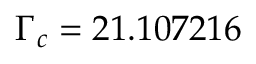Convert formula to latex. <formula><loc_0><loc_0><loc_500><loc_500>\Gamma _ { c } = 2 1 . 1 0 7 2 1 6</formula> 